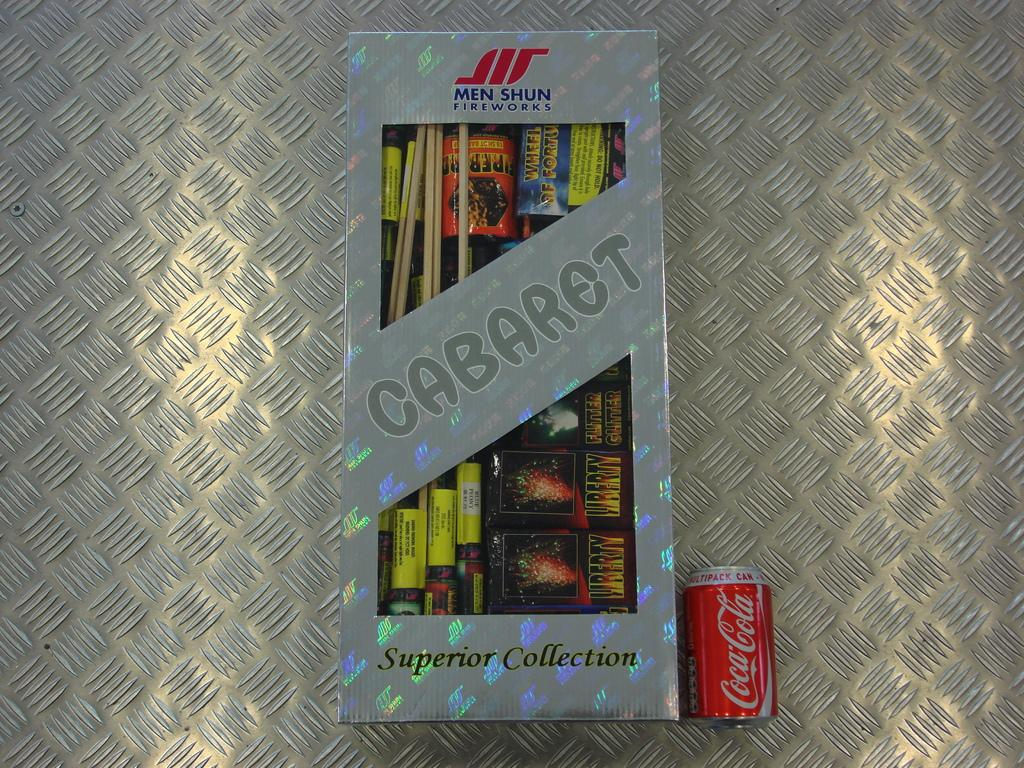<image>
Summarize the visual content of the image. A box of Cabaret Men Shun Fireworks sits next to a Coca-Cola can. 